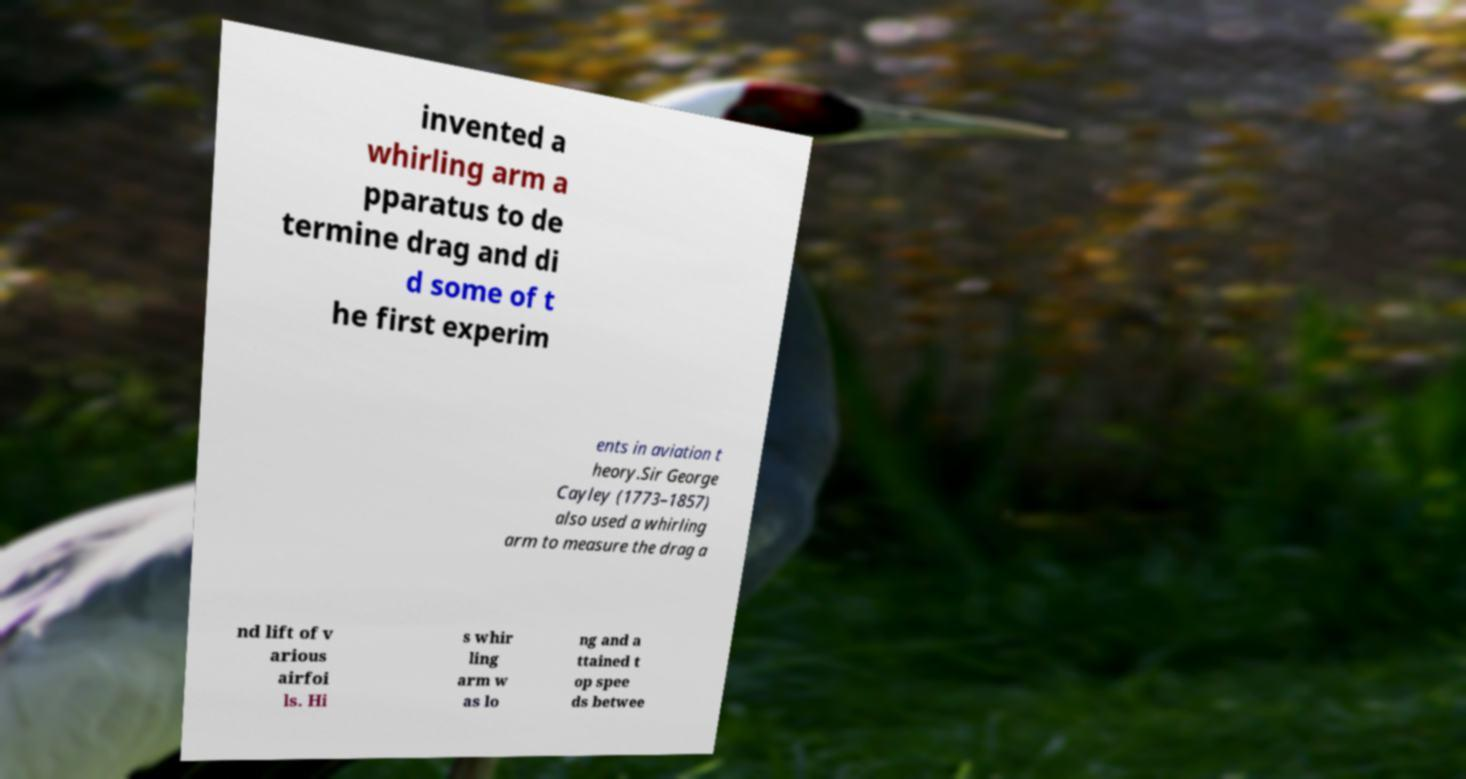What messages or text are displayed in this image? I need them in a readable, typed format. invented a whirling arm a pparatus to de termine drag and di d some of t he first experim ents in aviation t heory.Sir George Cayley (1773–1857) also used a whirling arm to measure the drag a nd lift of v arious airfoi ls. Hi s whir ling arm w as lo ng and a ttained t op spee ds betwee 